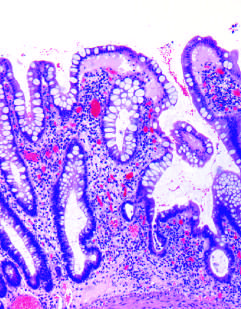does the head result from repeated injury and regeneration?
Answer the question using a single word or phrase. No 